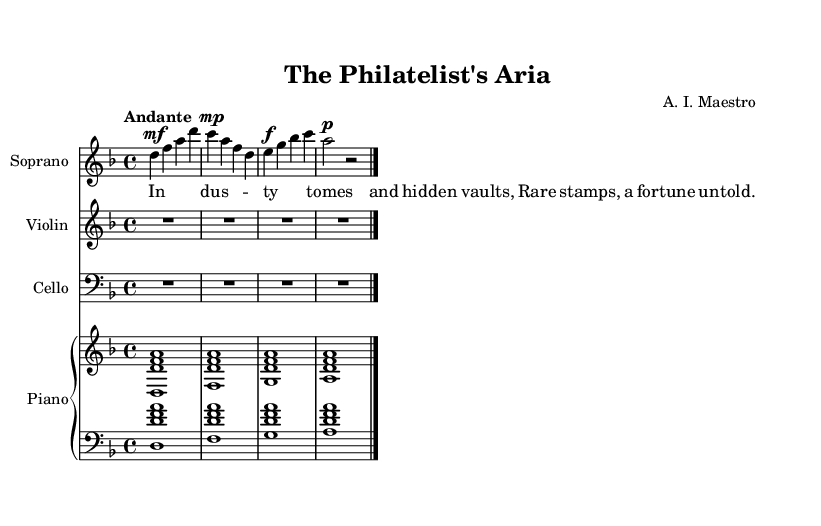What is the key signature of this music? The key signature indicated in the global section shows D minor, which contains one flat (B flat).
Answer: D minor What is the time signature of the piece? The time signature written in the global section is 4/4, meaning there are four beats per measure.
Answer: 4/4 What is the tempo marking for this music? The tempo marking provided in the global section is "Andante", which typically indicates a moderate walking pace.
Answer: Andante Which instrument plays the highest pitch in this composition? By analyzing the staves, the Soprano voice generally sings at a higher pitch than the Violin, Cello, and Piano parts.
Answer: Soprano How many measures are in the Soprano part? The Soprano part contains four measures, each separated by a bar line.
Answer: 4 What is the dynamic marking for the first phrase of the Soprano part? The first phrase starts with a mezzo-forte dynamic marking, indicated by the abbreviation "mf."
Answer: mezzo-forte Identify the thematic element in the lyrics. The lyrics mention "Rare stamps" and secretive locations, hinting at the theme of treasure hunting associated with collectible artifacts.
Answer: Rare stamps 